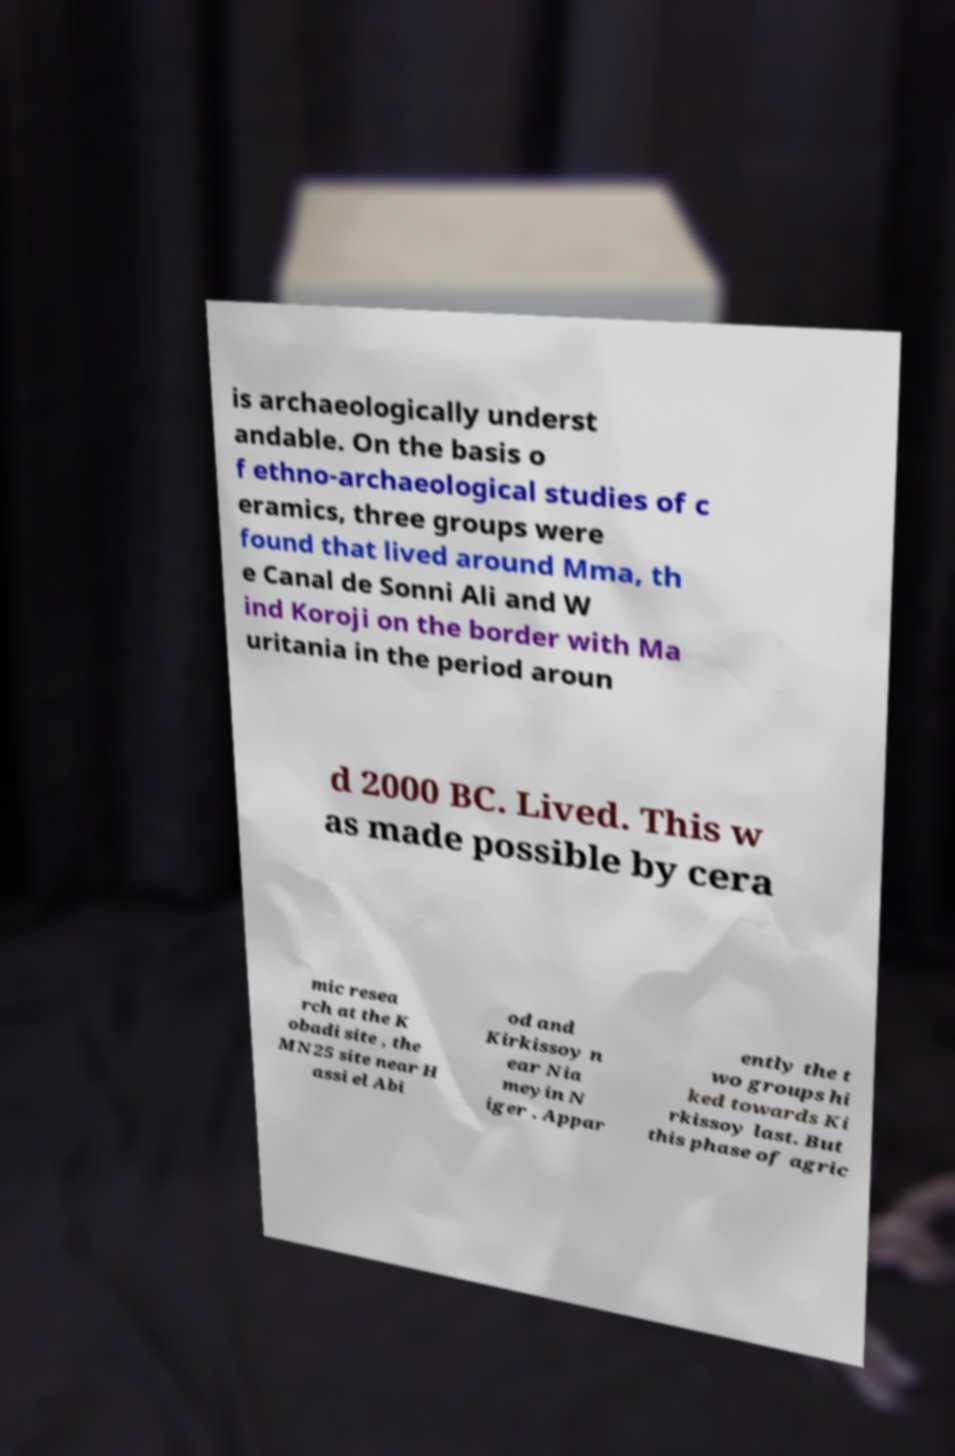Can you read and provide the text displayed in the image?This photo seems to have some interesting text. Can you extract and type it out for me? is archaeologically underst andable. On the basis o f ethno-archaeological studies of c eramics, three groups were found that lived around Mma, th e Canal de Sonni Ali and W ind Koroji on the border with Ma uritania in the period aroun d 2000 BC. Lived. This w as made possible by cera mic resea rch at the K obadi site , the MN25 site near H assi el Abi od and Kirkissoy n ear Nia meyin N iger . Appar ently the t wo groups hi ked towards Ki rkissoy last. But this phase of agric 